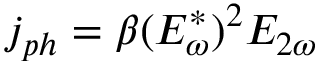Convert formula to latex. <formula><loc_0><loc_0><loc_500><loc_500>j _ { p h } = \beta ( E _ { \omega } ^ { * } ) ^ { 2 } E _ { 2 \omega }</formula> 